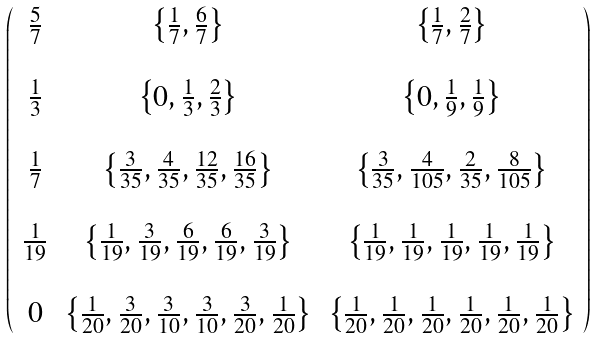Convert formula to latex. <formula><loc_0><loc_0><loc_500><loc_500>\left ( \begin{array} { c c c } \frac { 5 } { 7 } & \left \{ \frac { 1 } { 7 } , \frac { 6 } { 7 } \right \} & \left \{ \frac { 1 } { 7 } , \frac { 2 } { 7 } \right \} \\ \\ \frac { 1 } { 3 } & \left \{ 0 , \frac { 1 } { 3 } , \frac { 2 } { 3 } \right \} & \left \{ 0 , \frac { 1 } { 9 } , \frac { 1 } { 9 } \right \} \\ \\ \frac { 1 } { 7 } & \left \{ \frac { 3 } { 3 5 } , \frac { 4 } { 3 5 } , \frac { 1 2 } { 3 5 } , \frac { 1 6 } { 3 5 } \right \} & \left \{ \frac { 3 } { 3 5 } , \frac { 4 } { 1 0 5 } , \frac { 2 } { 3 5 } , \frac { 8 } { 1 0 5 } \right \} \\ \\ \frac { 1 } { 1 9 } & \left \{ \frac { 1 } { 1 9 } , \frac { 3 } { 1 9 } , \frac { 6 } { 1 9 } , \frac { 6 } { 1 9 } , \frac { 3 } { 1 9 } \right \} & \left \{ \frac { 1 } { 1 9 } , \frac { 1 } { 1 9 } , \frac { 1 } { 1 9 } , \frac { 1 } { 1 9 } , \frac { 1 } { 1 9 } \right \} \\ \\ 0 & \left \{ \frac { 1 } { 2 0 } , \frac { 3 } { 2 0 } , \frac { 3 } { 1 0 } , \frac { 3 } { 1 0 } , \frac { 3 } { 2 0 } , \frac { 1 } { 2 0 } \right \} & \left \{ \frac { 1 } { 2 0 } , \frac { 1 } { 2 0 } , \frac { 1 } { 2 0 } , \frac { 1 } { 2 0 } , \frac { 1 } { 2 0 } , \frac { 1 } { 2 0 } \right \} \\ \end{array} \right )</formula> 